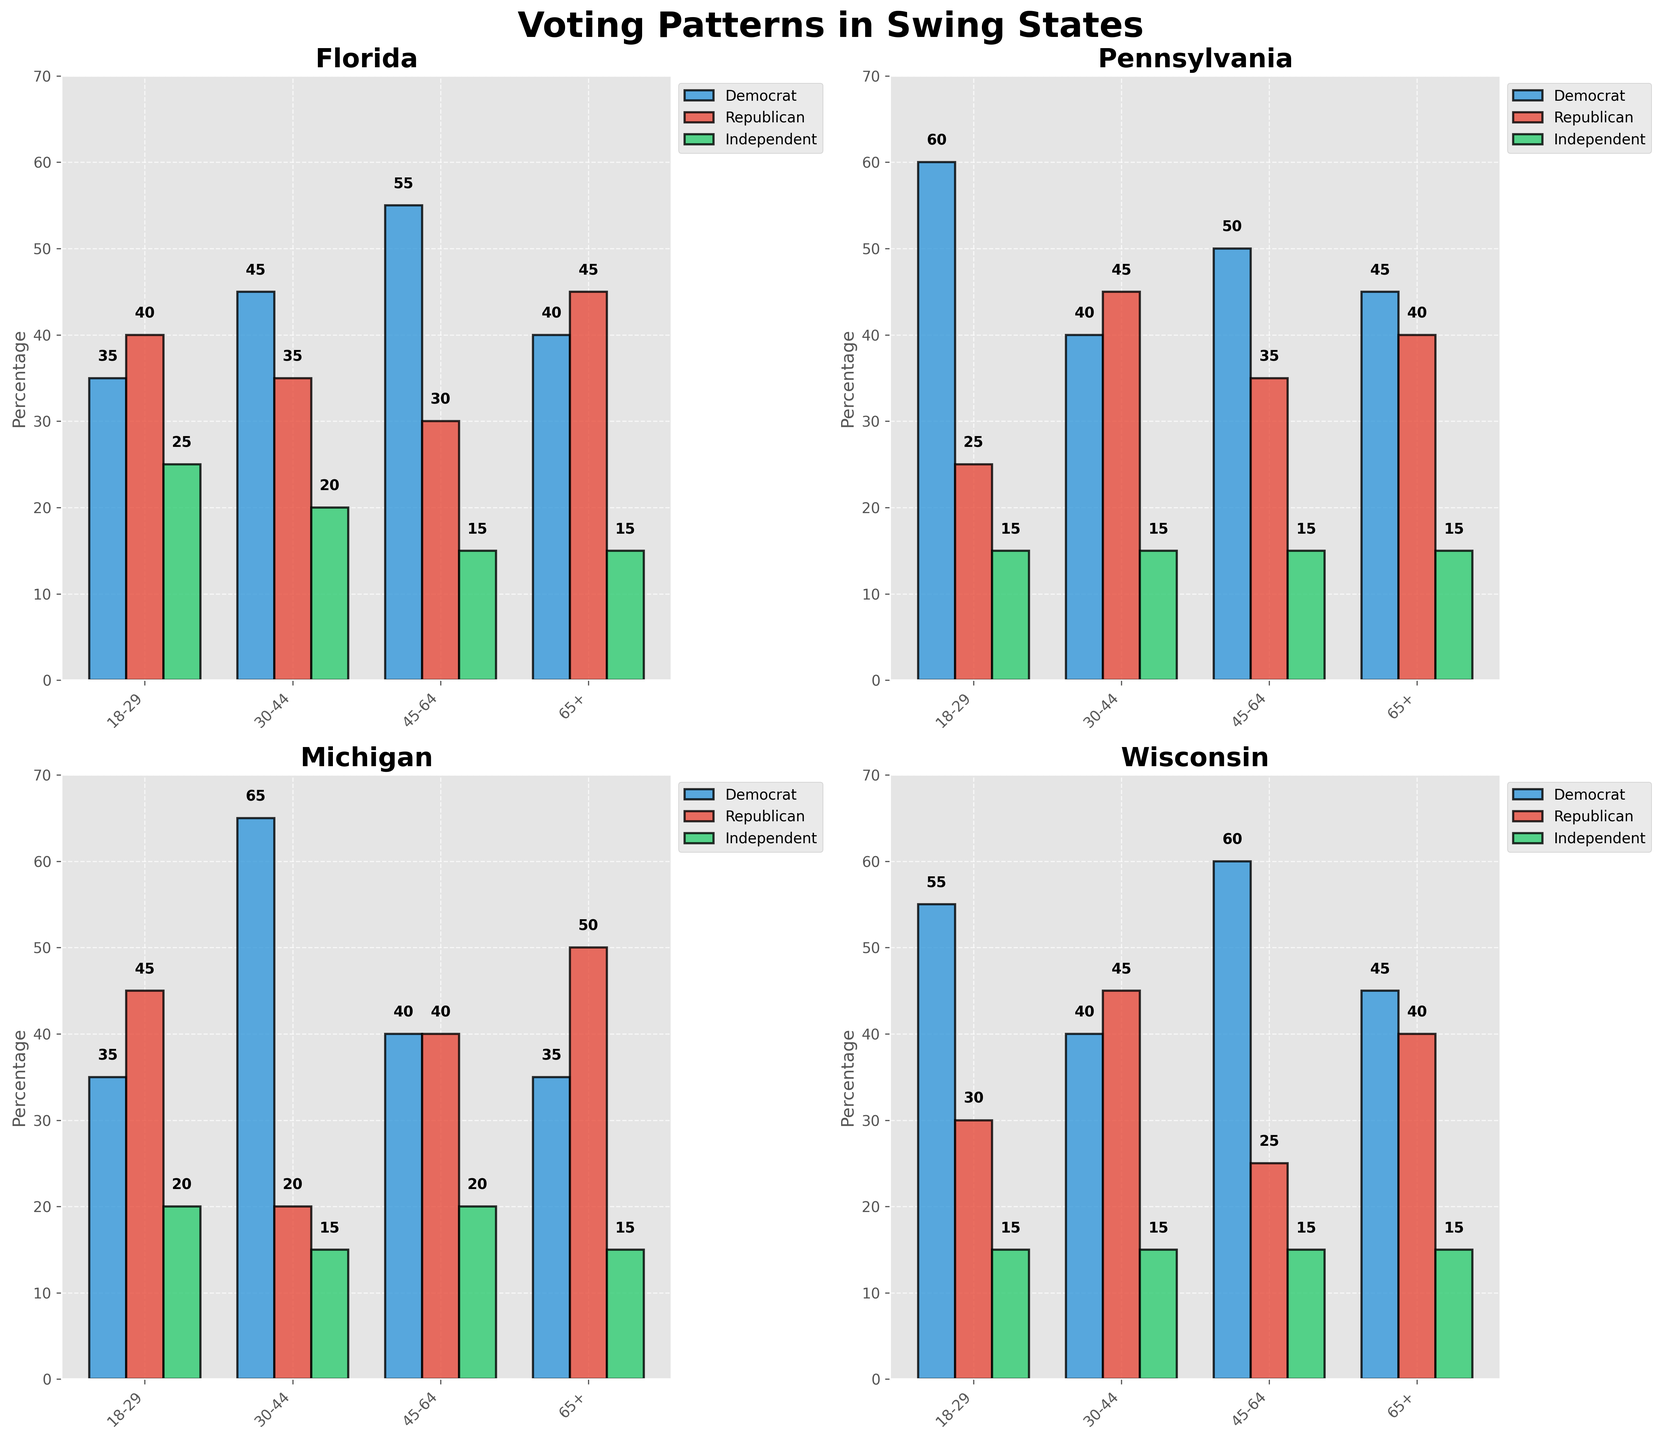What is the title of the plot? The title of the plot is located at the top of the figure and gives an overview of the entire figure. It states ‘Voting Patterns in Swing States,’ which indicates that the figure shows different voting patterns among swing states.
Answer: Voting Patterns in Swing States What are the three parties represented in the plot? The three parties are represented by different colors in the bar charts across all subplots. They are indicated in the legend and are represented as Democrat, Republican, and Independent.
Answer: Democrat, Republican, Independent Which party had the highest percentage in Michigan for the age group 30-44? To find this, look at the Michigan subplot and the bars for the 30-44 age group. The bar representing Democrat is the tallest.
Answer: Democrat What is the overall highest percentage recorded in any demographic group across all states? To determine the highest percentage recorded, look across all the subplots for the maximum bar height. The highest is 65% in Michigan's 30-44 age group.
Answer: 65% Which state has the highest percentage of young adults (18-29) voting for Democrats? To determine this, look at the 18-29 age group bar for Democrats in all subplots. Pennsylvania has the highest at 60%.
Answer: Pennsylvania What is the percentage difference between Democrats and Republicans for the age group 65+ in Wisconsin? Find the values for the 65+ age group in Wisconsin for both Democrats (45) and Republicans (40). The difference is 45 - 40 = 5%.
Answer: 5% In Florida, which age group has the highest percentage of Independent voters? To determine this, look at the heights of the green bars representing Independent voters for each age group in the Florida subplot. The 18-29 age group has the highest percentage at 25%.
Answer: 18-29 How does the voting pattern of middle-income Hispanic voters in Florida compare to that in Pennsylvania? Compare the bar heights for the 30-44 age group Hispanic voters (middle income) in both subplots. In Florida, Democrats are higher (45%), whereas in Pennsylvania it’s the Republicans (45%).
Answer: Florida: Democrats, Pennsylvania: Republicans Among the swing states, which state shows the most balanced distribution of voters between the three parties for any age group? Find the age group within a state where the bar heights for Democrat, Republican, and Independent are the closest. In Florida's 30-44 age group, the percentages are 45% (Democrat), 35% (Republican), and 20% (Independent). This is a fairly balanced distribution.
Answer: Florida, 30-44 Which demographic group in Pennsylvania shows the least support for Republicans? To determine this, look at all bars representing Republican voters in Pennsylvania and find the shortest. The 18-29 age group has the least support at 25%.
Answer: 18-29 